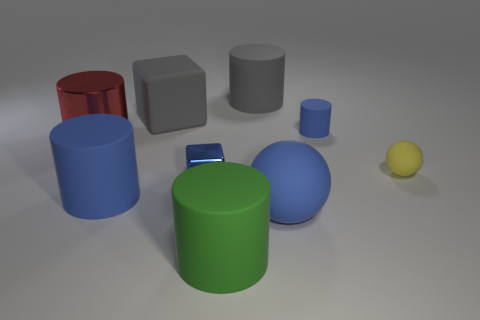Subtract 1 cylinders. How many cylinders are left? 4 Subtract all green cylinders. How many cylinders are left? 4 Subtract all green cylinders. How many cylinders are left? 4 Subtract all yellow cylinders. Subtract all purple balls. How many cylinders are left? 5 Add 1 large red shiny cylinders. How many objects exist? 10 Subtract all cubes. How many objects are left? 7 Subtract all small cyan shiny cylinders. Subtract all tiny blue metallic things. How many objects are left? 8 Add 9 large rubber balls. How many large rubber balls are left? 10 Add 2 small yellow objects. How many small yellow objects exist? 3 Subtract 0 yellow blocks. How many objects are left? 9 